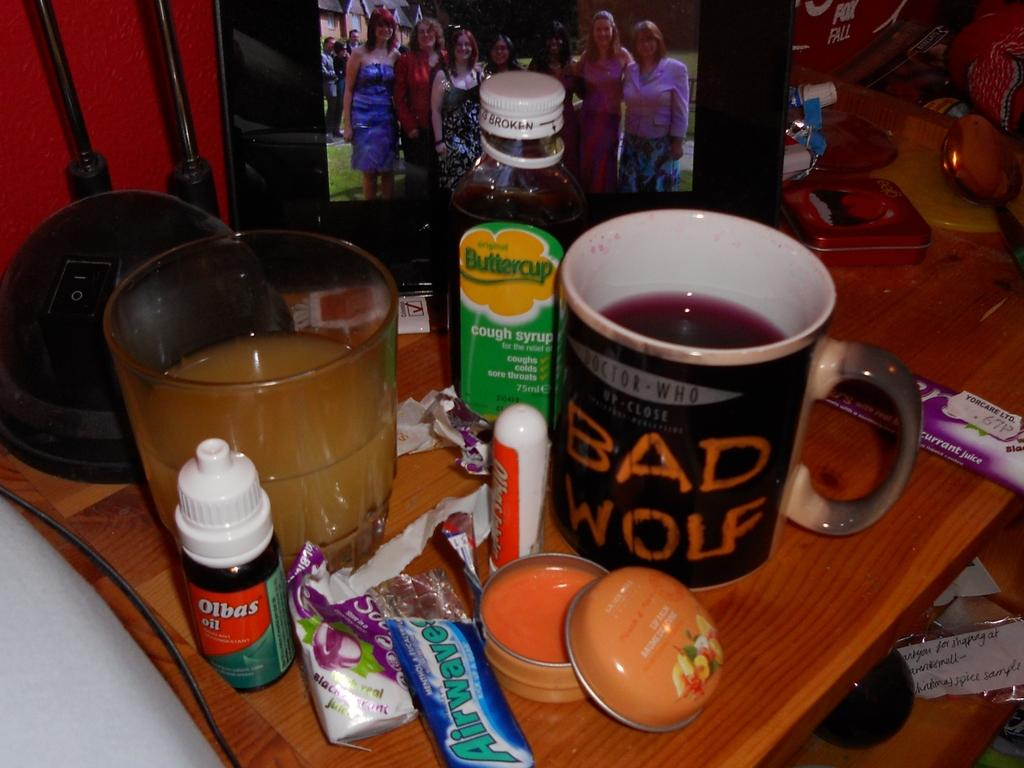<image>
Write a terse but informative summary of the picture. A green mug that has the words "Bad wolf" on it. 